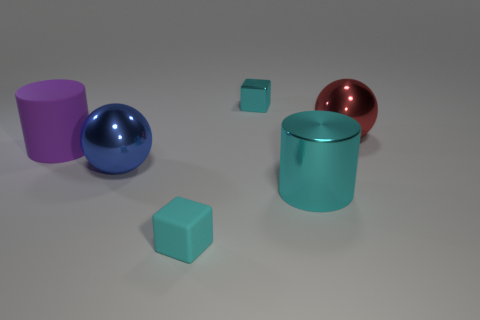Which object looks to be the largest? The turquoise cylinder appears to be the largest object in the image when considering both height and volume. Is the red sphere larger than the blue one? No, the red sphere is smaller than the blue sphere when comparing their sizes in the image. 